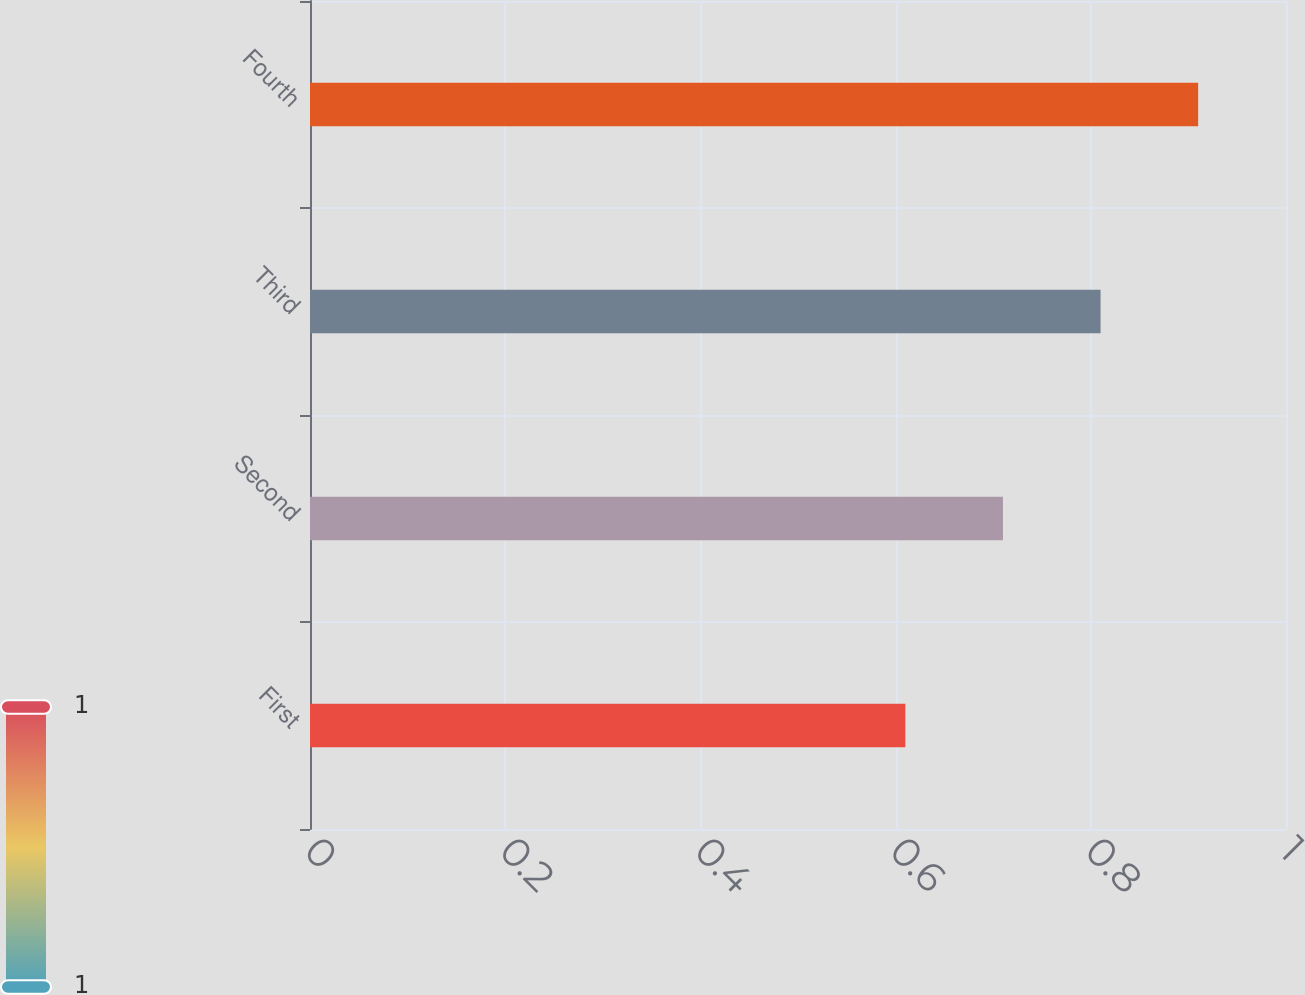Convert chart. <chart><loc_0><loc_0><loc_500><loc_500><bar_chart><fcel>First<fcel>Second<fcel>Third<fcel>Fourth<nl><fcel>0.61<fcel>0.71<fcel>0.81<fcel>0.91<nl></chart> 